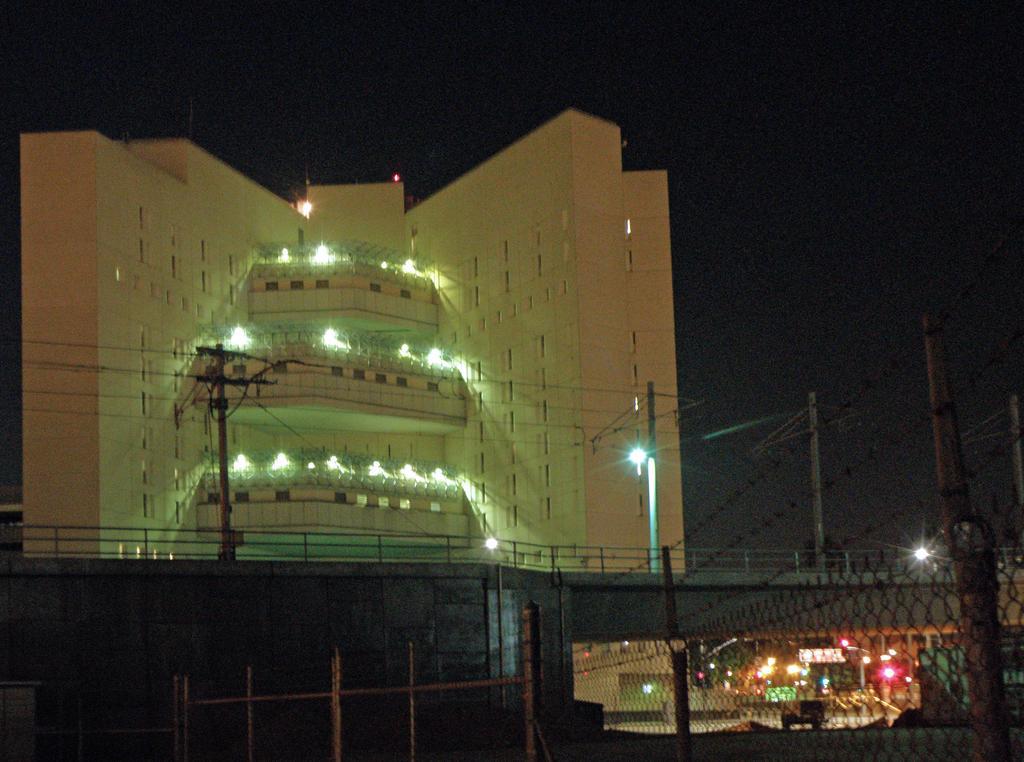Describe this image in one or two sentences. There is a mesh fencing. In the back there is a bridge. On that there are electric poles with wires. In the background there are lights. And there is a building with lights. And it is dark in the background. 